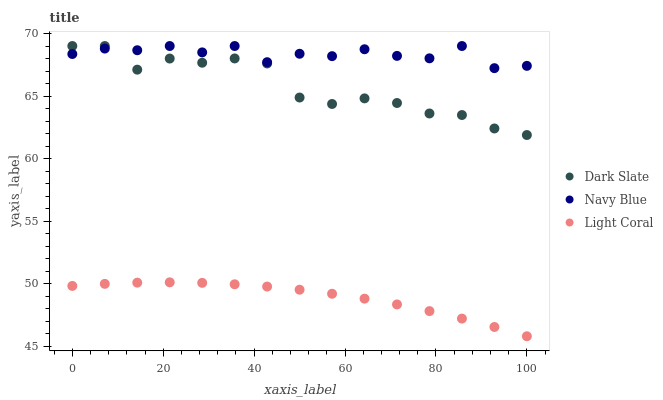Does Light Coral have the minimum area under the curve?
Answer yes or no. Yes. Does Navy Blue have the maximum area under the curve?
Answer yes or no. Yes. Does Dark Slate have the minimum area under the curve?
Answer yes or no. No. Does Dark Slate have the maximum area under the curve?
Answer yes or no. No. Is Light Coral the smoothest?
Answer yes or no. Yes. Is Dark Slate the roughest?
Answer yes or no. Yes. Is Navy Blue the smoothest?
Answer yes or no. No. Is Navy Blue the roughest?
Answer yes or no. No. Does Light Coral have the lowest value?
Answer yes or no. Yes. Does Dark Slate have the lowest value?
Answer yes or no. No. Does Navy Blue have the highest value?
Answer yes or no. Yes. Is Light Coral less than Navy Blue?
Answer yes or no. Yes. Is Dark Slate greater than Light Coral?
Answer yes or no. Yes. Does Dark Slate intersect Navy Blue?
Answer yes or no. Yes. Is Dark Slate less than Navy Blue?
Answer yes or no. No. Is Dark Slate greater than Navy Blue?
Answer yes or no. No. Does Light Coral intersect Navy Blue?
Answer yes or no. No. 